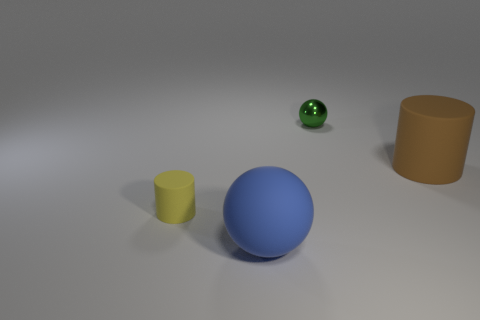Which object appears to be the closest to the foreground? In the foreground, the blue sphere is the closest object to the viewer. It is significantly larger in appearance than the other objects, indicating its position at the front of the scene. Do you think that the size of these objects has been altered for artistic effect, or do they represent their real-life counterparts? Given the context of the image, which lacks real-world reference points, it's difficult to ascertain whether the sizes are altered artistically or if they're meant to represent real-life counterparts. However, the varying sizes could be an intentional artistic choice to create depth and perspective within the composition, or alternatively, it could be a realistic depiction of objects at different distances from the viewer. 